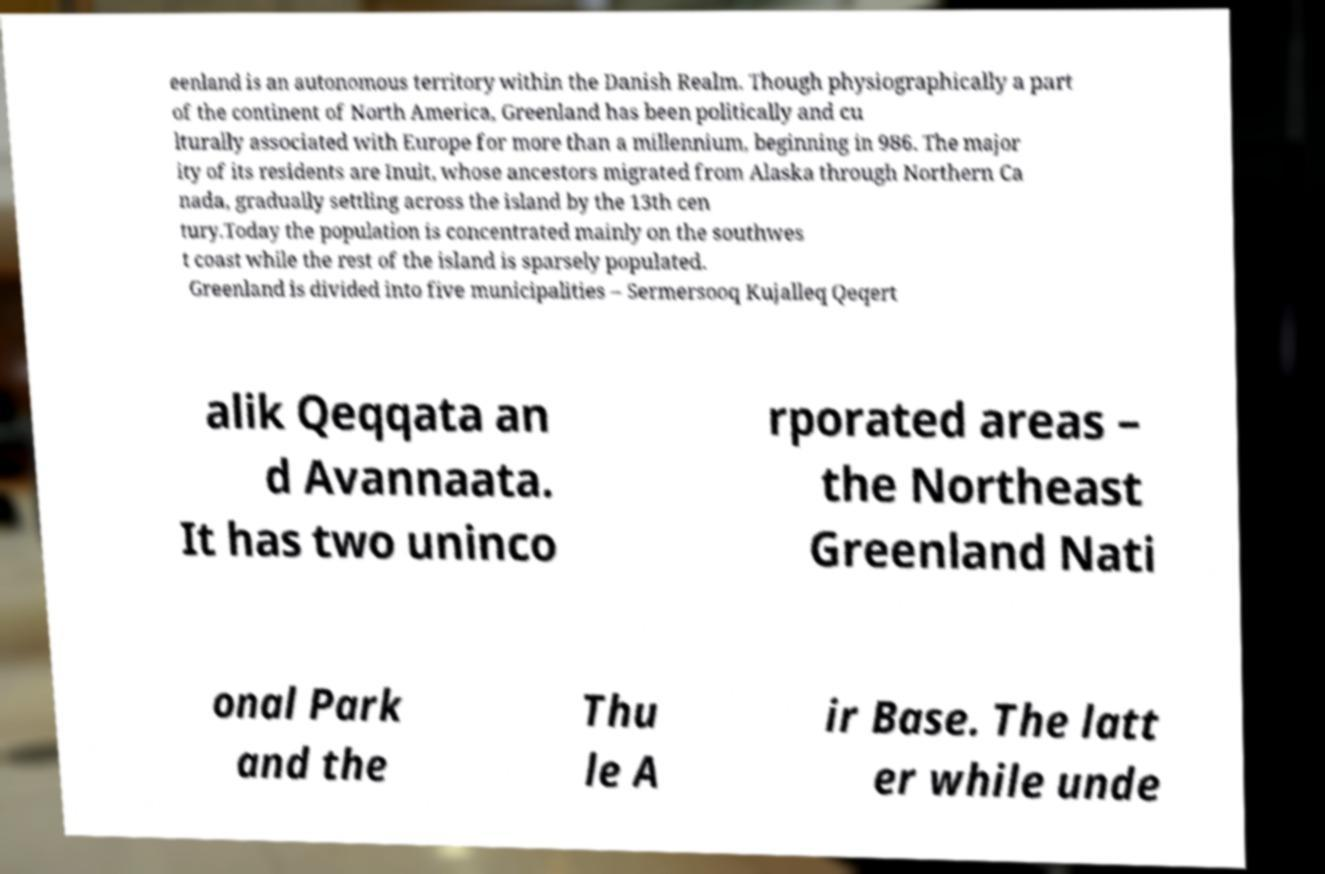Can you read and provide the text displayed in the image?This photo seems to have some interesting text. Can you extract and type it out for me? eenland is an autonomous territory within the Danish Realm. Though physiographically a part of the continent of North America, Greenland has been politically and cu lturally associated with Europe for more than a millennium, beginning in 986. The major ity of its residents are Inuit, whose ancestors migrated from Alaska through Northern Ca nada, gradually settling across the island by the 13th cen tury.Today the population is concentrated mainly on the southwes t coast while the rest of the island is sparsely populated. Greenland is divided into five municipalities – Sermersooq Kujalleq Qeqert alik Qeqqata an d Avannaata. It has two uninco rporated areas – the Northeast Greenland Nati onal Park and the Thu le A ir Base. The latt er while unde 